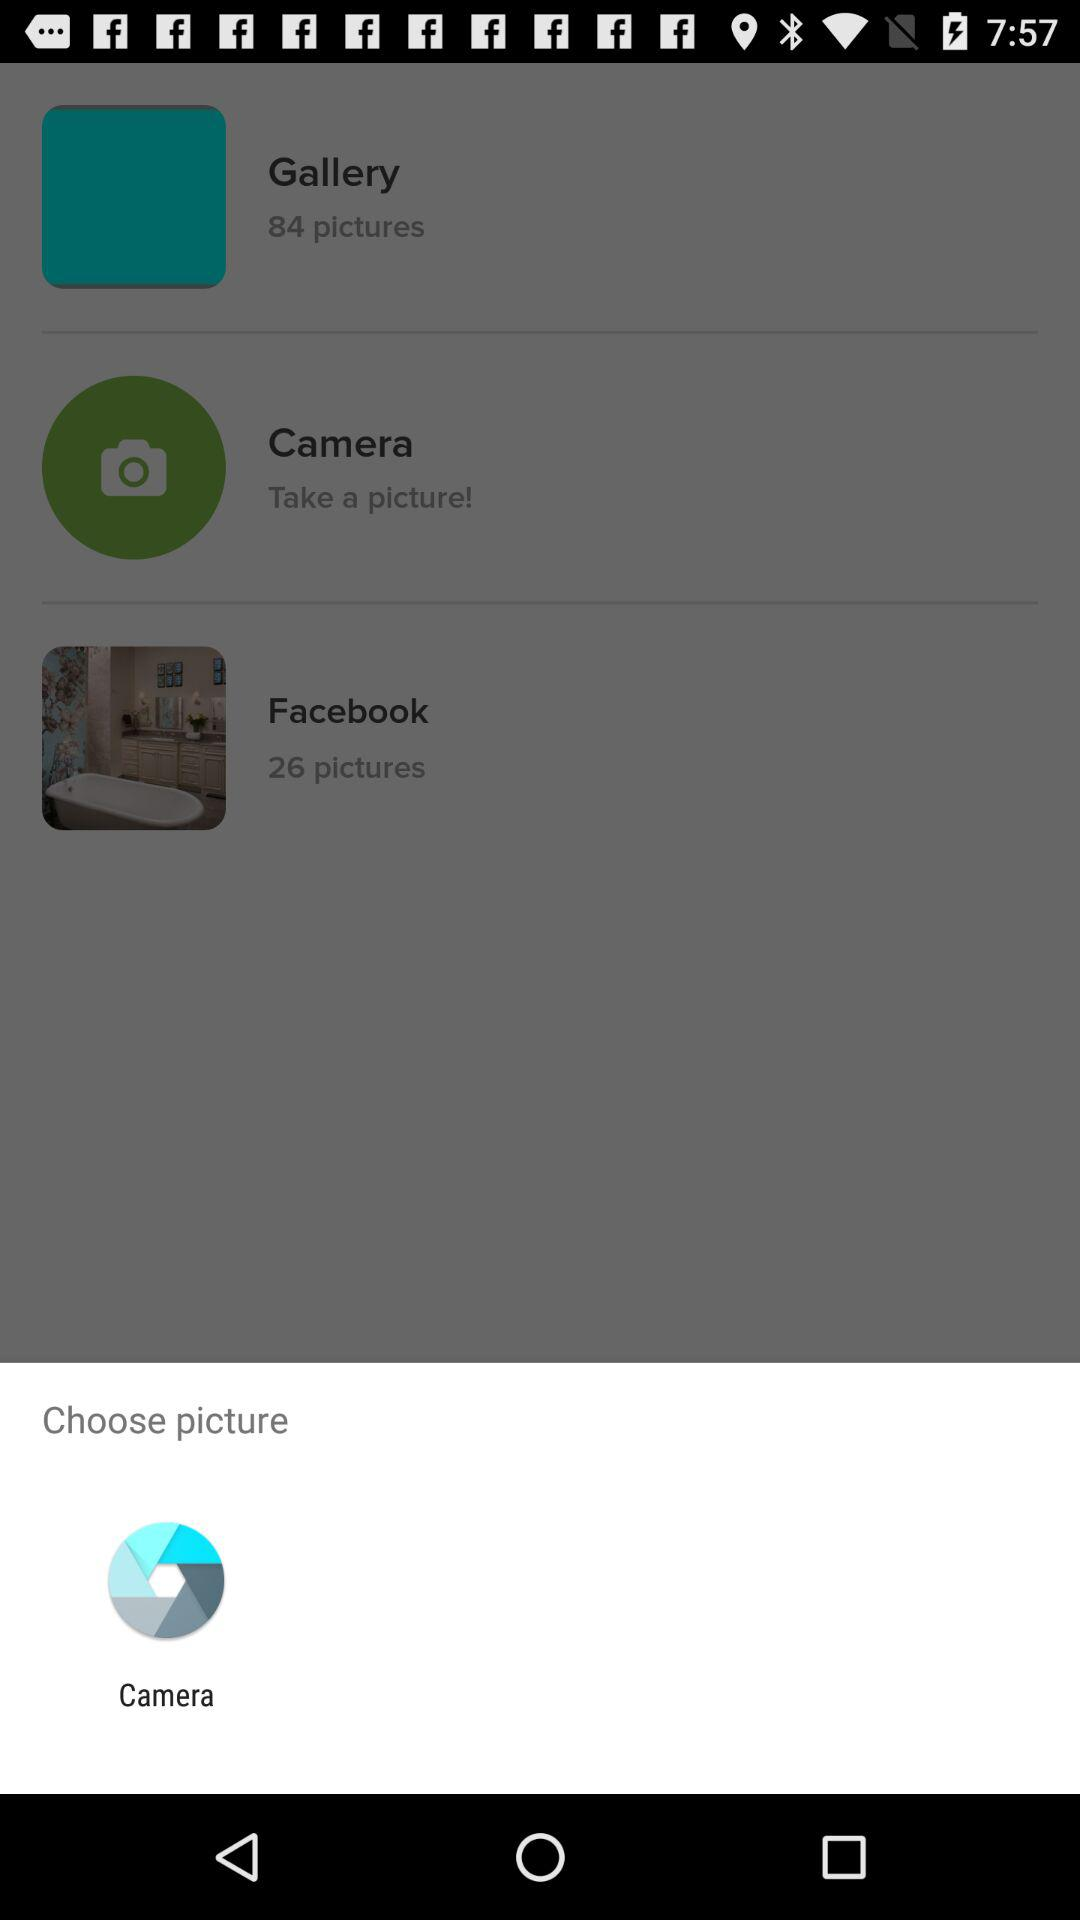What application can be used to choose pictures? The application that can be used to choose pictures is "Camera". 